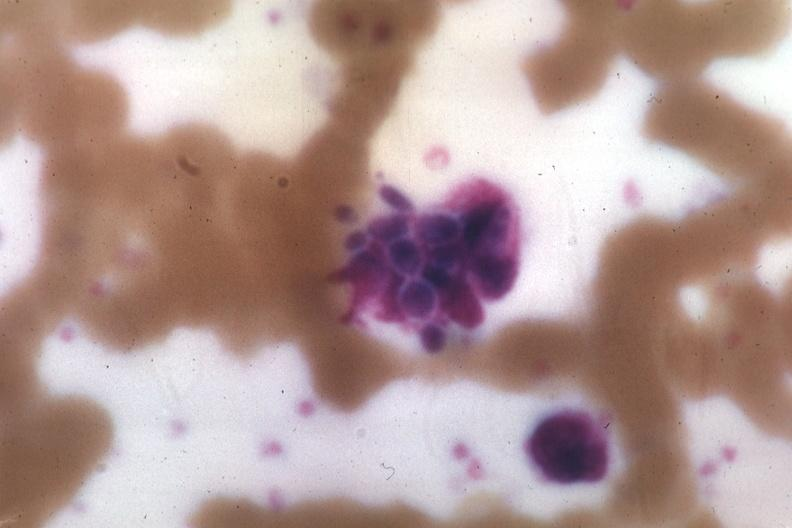s candida in peripheral blood present?
Answer the question using a single word or phrase. Yes 